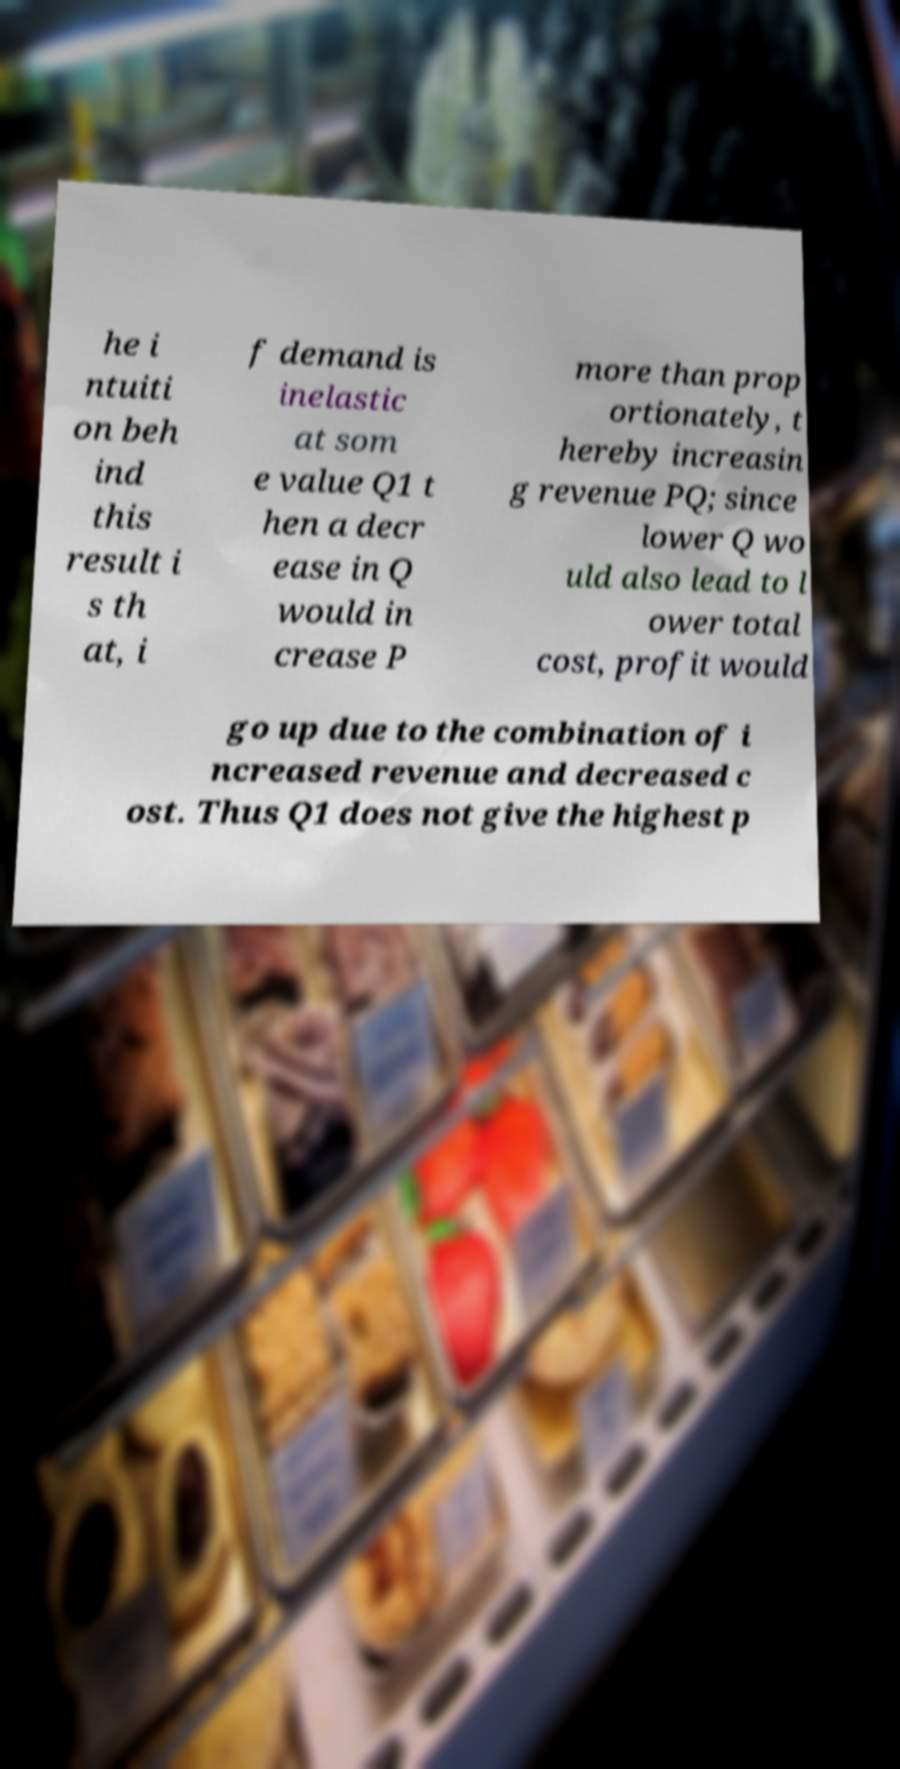Can you accurately transcribe the text from the provided image for me? he i ntuiti on beh ind this result i s th at, i f demand is inelastic at som e value Q1 t hen a decr ease in Q would in crease P more than prop ortionately, t hereby increasin g revenue PQ; since lower Q wo uld also lead to l ower total cost, profit would go up due to the combination of i ncreased revenue and decreased c ost. Thus Q1 does not give the highest p 